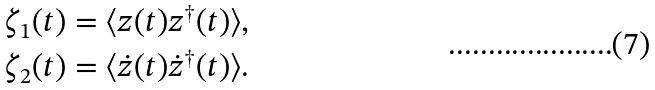<formula> <loc_0><loc_0><loc_500><loc_500>\zeta _ { 1 } ( t ) = \langle z ( t ) z ^ { \dagger } ( t ) \rangle , \\ \zeta _ { 2 } ( t ) = \langle \dot { z } ( t ) \dot { z } ^ { \dagger } ( t ) \rangle .</formula> 